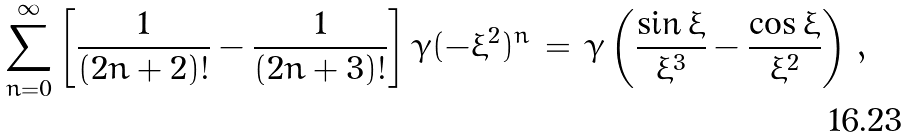<formula> <loc_0><loc_0><loc_500><loc_500>\sum ^ { \infty } _ { n = 0 } \left [ \frac { 1 } { ( 2 n + 2 ) ! } - \frac { 1 } { ( 2 n + 3 ) ! } \right ] \gamma ( - \xi ^ { 2 } ) ^ { n } \, = \, \gamma \left ( \frac { \sin \xi } { \xi ^ { 3 } } - \frac { \cos \xi } { \xi ^ { 2 } } \right ) \, ,</formula> 